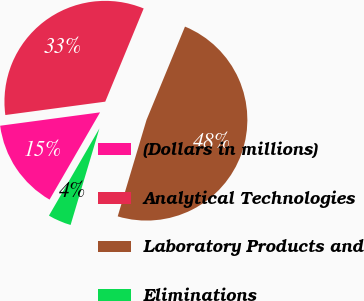Convert chart to OTSL. <chart><loc_0><loc_0><loc_500><loc_500><pie_chart><fcel>(Dollars in millions)<fcel>Analytical Technologies<fcel>Laboratory Products and<fcel>Eliminations<nl><fcel>14.53%<fcel>33.34%<fcel>48.39%<fcel>3.73%<nl></chart> 